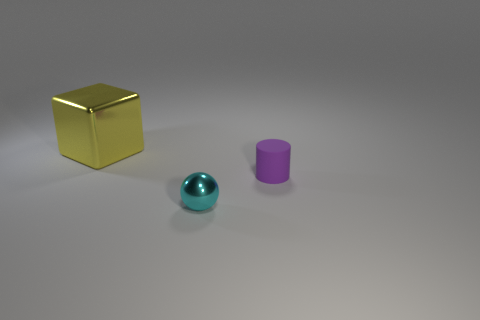Add 2 matte cylinders. How many objects exist? 5 Subtract all balls. How many objects are left? 2 Subtract all large cyan metal things. Subtract all large yellow metal blocks. How many objects are left? 2 Add 1 tiny cyan metal objects. How many tiny cyan metal objects are left? 2 Add 1 tiny yellow things. How many tiny yellow things exist? 1 Subtract 0 brown cylinders. How many objects are left? 3 